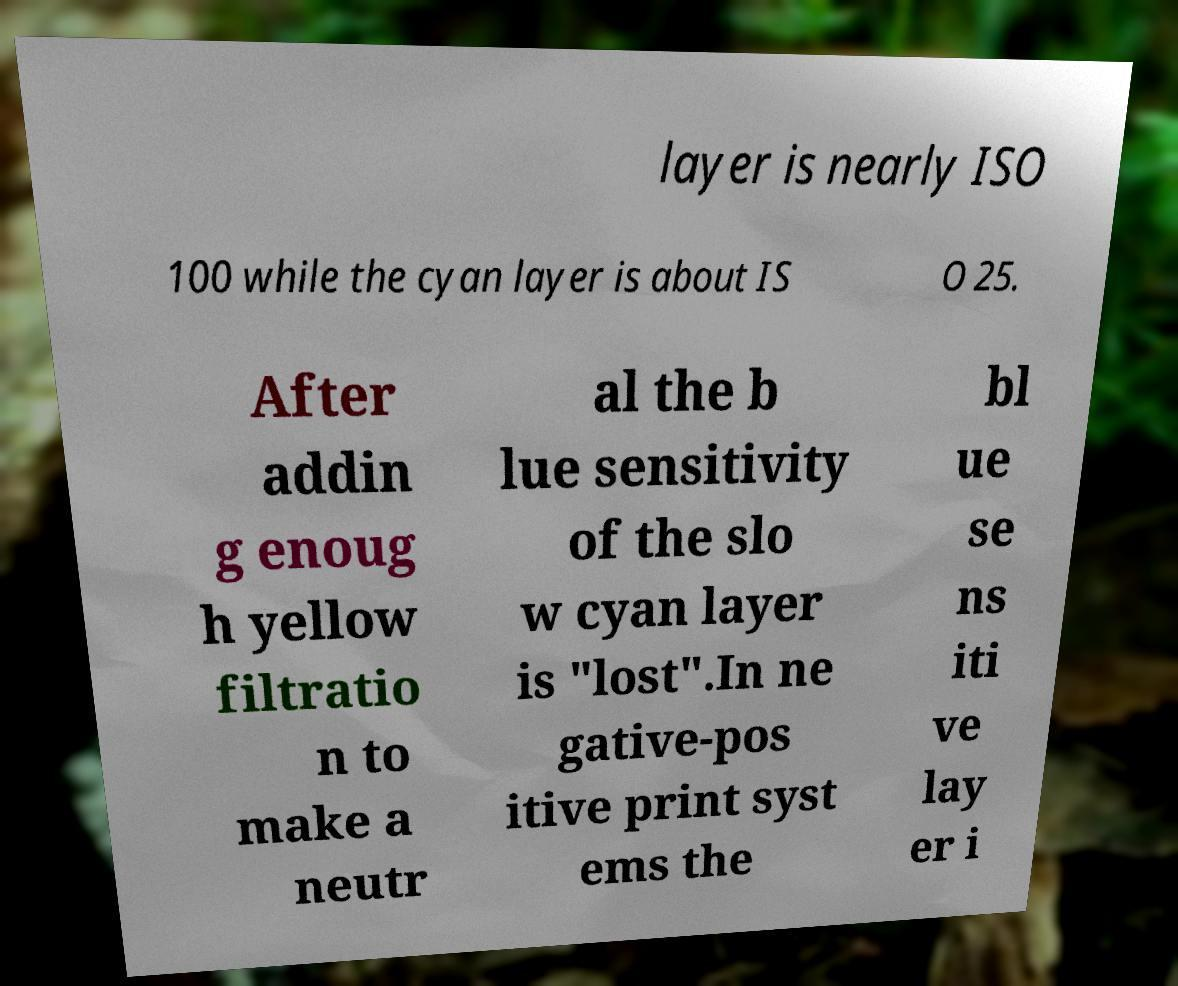Please identify and transcribe the text found in this image. layer is nearly ISO 100 while the cyan layer is about IS O 25. After addin g enoug h yellow filtratio n to make a neutr al the b lue sensitivity of the slo w cyan layer is "lost".In ne gative-pos itive print syst ems the bl ue se ns iti ve lay er i 